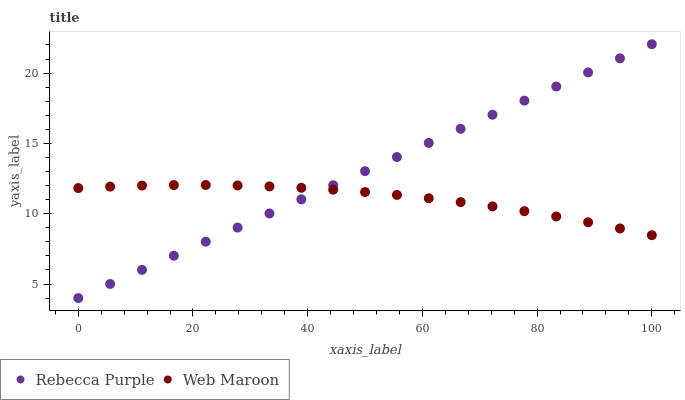Does Web Maroon have the minimum area under the curve?
Answer yes or no. Yes. Does Rebecca Purple have the maximum area under the curve?
Answer yes or no. Yes. Does Rebecca Purple have the minimum area under the curve?
Answer yes or no. No. Is Rebecca Purple the smoothest?
Answer yes or no. Yes. Is Web Maroon the roughest?
Answer yes or no. Yes. Is Rebecca Purple the roughest?
Answer yes or no. No. Does Rebecca Purple have the lowest value?
Answer yes or no. Yes. Does Rebecca Purple have the highest value?
Answer yes or no. Yes. Does Web Maroon intersect Rebecca Purple?
Answer yes or no. Yes. Is Web Maroon less than Rebecca Purple?
Answer yes or no. No. Is Web Maroon greater than Rebecca Purple?
Answer yes or no. No. 